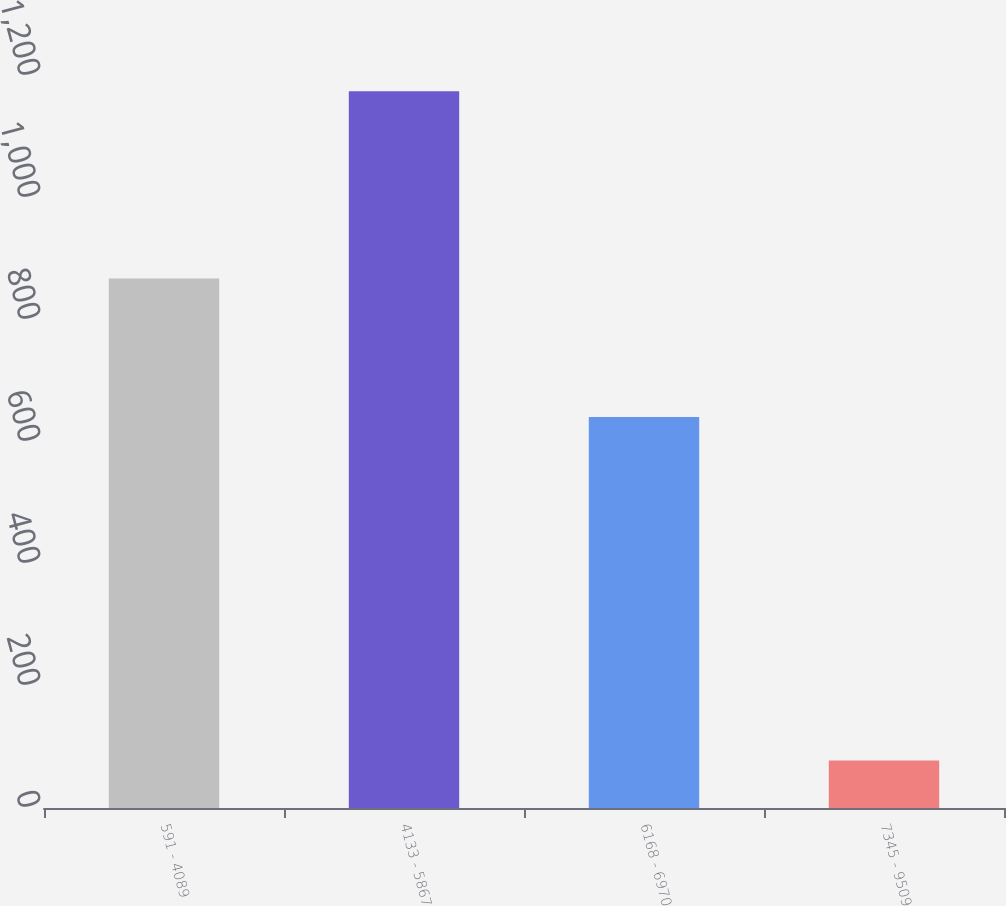Convert chart. <chart><loc_0><loc_0><loc_500><loc_500><bar_chart><fcel>591 - 4089<fcel>4133 - 5867<fcel>6168 - 6970<fcel>7345 - 9509<nl><fcel>868<fcel>1175<fcel>641<fcel>78<nl></chart> 